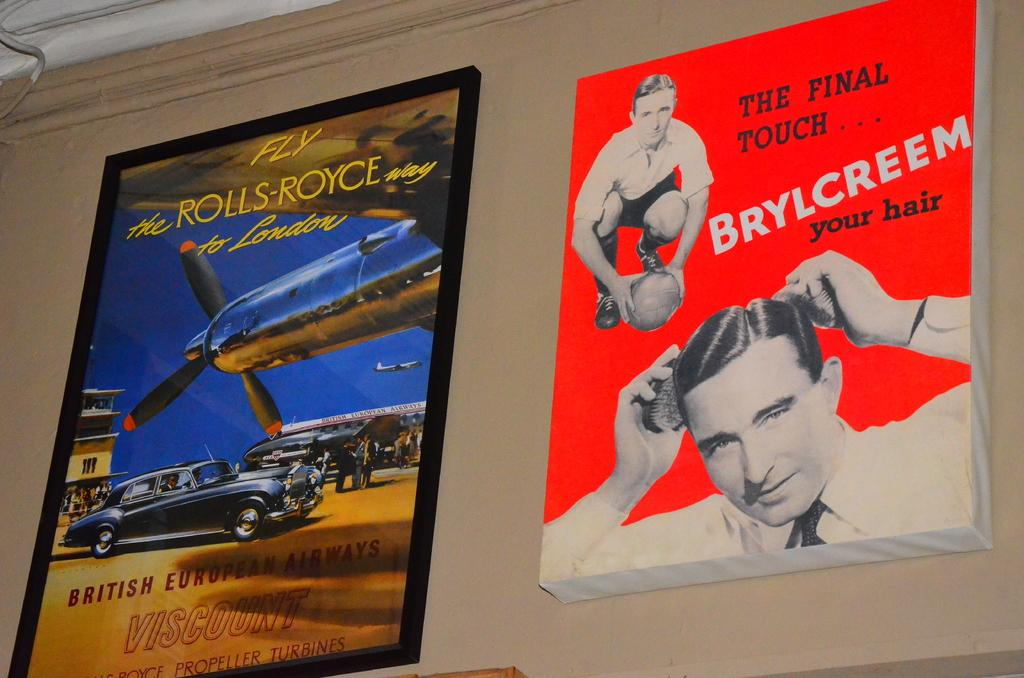<image>
Write a terse but informative summary of the picture. Fly the rolls royce way to London poster and the final touch Brylcreem your hair poster on a wall. 